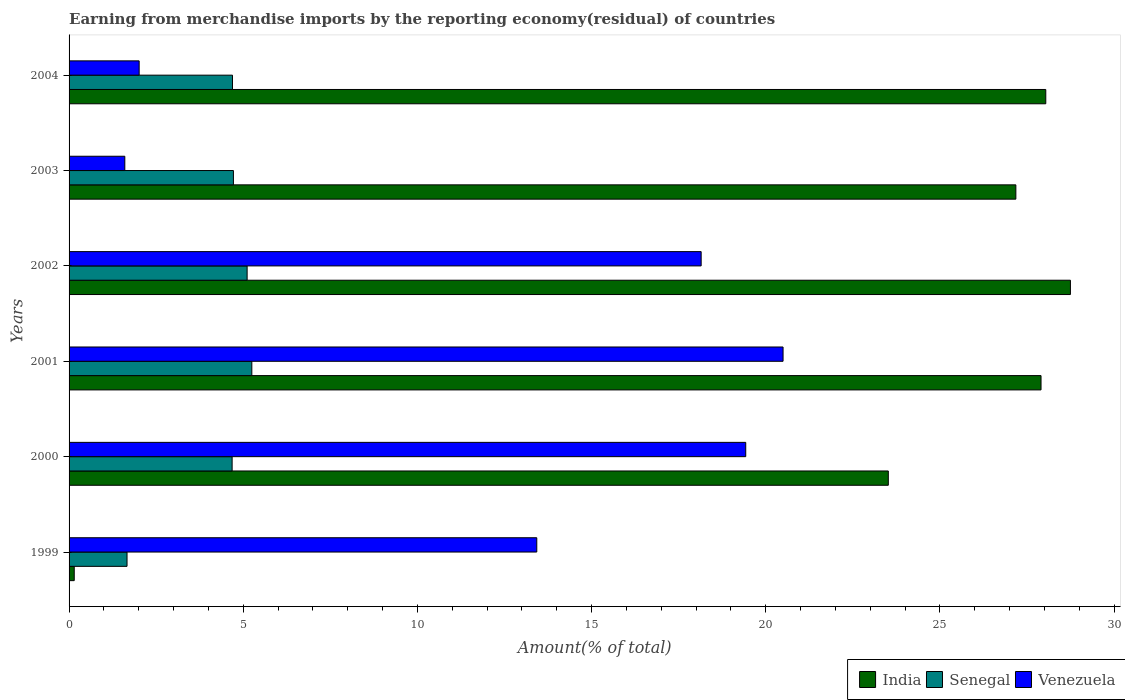How many different coloured bars are there?
Make the answer very short. 3. Are the number of bars on each tick of the Y-axis equal?
Keep it short and to the point. Yes. How many bars are there on the 2nd tick from the top?
Make the answer very short. 3. What is the label of the 3rd group of bars from the top?
Your response must be concise. 2002. What is the percentage of amount earned from merchandise imports in India in 2000?
Your answer should be very brief. 23.52. Across all years, what is the maximum percentage of amount earned from merchandise imports in India?
Give a very brief answer. 28.75. Across all years, what is the minimum percentage of amount earned from merchandise imports in Venezuela?
Keep it short and to the point. 1.6. In which year was the percentage of amount earned from merchandise imports in Venezuela maximum?
Ensure brevity in your answer.  2001. In which year was the percentage of amount earned from merchandise imports in Venezuela minimum?
Provide a short and direct response. 2003. What is the total percentage of amount earned from merchandise imports in India in the graph?
Ensure brevity in your answer.  135.53. What is the difference between the percentage of amount earned from merchandise imports in India in 2001 and that in 2003?
Your answer should be very brief. 0.72. What is the difference between the percentage of amount earned from merchandise imports in Senegal in 2001 and the percentage of amount earned from merchandise imports in India in 2003?
Give a very brief answer. -21.93. What is the average percentage of amount earned from merchandise imports in India per year?
Provide a short and direct response. 22.59. In the year 2000, what is the difference between the percentage of amount earned from merchandise imports in India and percentage of amount earned from merchandise imports in Senegal?
Keep it short and to the point. 18.84. What is the ratio of the percentage of amount earned from merchandise imports in Venezuela in 1999 to that in 2003?
Your answer should be compact. 8.39. What is the difference between the highest and the second highest percentage of amount earned from merchandise imports in India?
Your answer should be compact. 0.71. What is the difference between the highest and the lowest percentage of amount earned from merchandise imports in Venezuela?
Make the answer very short. 18.9. What does the 3rd bar from the top in 2002 represents?
Your response must be concise. India. What does the 1st bar from the bottom in 2002 represents?
Offer a very short reply. India. How many bars are there?
Keep it short and to the point. 18. Are all the bars in the graph horizontal?
Your response must be concise. Yes. How many years are there in the graph?
Give a very brief answer. 6. Are the values on the major ticks of X-axis written in scientific E-notation?
Make the answer very short. No. How many legend labels are there?
Your answer should be very brief. 3. How are the legend labels stacked?
Provide a short and direct response. Horizontal. What is the title of the graph?
Provide a succinct answer. Earning from merchandise imports by the reporting economy(residual) of countries. Does "Jordan" appear as one of the legend labels in the graph?
Your response must be concise. No. What is the label or title of the X-axis?
Keep it short and to the point. Amount(% of total). What is the Amount(% of total) in India in 1999?
Your response must be concise. 0.15. What is the Amount(% of total) of Senegal in 1999?
Your response must be concise. 1.66. What is the Amount(% of total) of Venezuela in 1999?
Make the answer very short. 13.43. What is the Amount(% of total) in India in 2000?
Your answer should be very brief. 23.52. What is the Amount(% of total) of Senegal in 2000?
Offer a terse response. 4.68. What is the Amount(% of total) of Venezuela in 2000?
Offer a terse response. 19.42. What is the Amount(% of total) of India in 2001?
Ensure brevity in your answer.  27.9. What is the Amount(% of total) in Senegal in 2001?
Provide a short and direct response. 5.25. What is the Amount(% of total) in Venezuela in 2001?
Your answer should be compact. 20.5. What is the Amount(% of total) of India in 2002?
Your answer should be compact. 28.75. What is the Amount(% of total) in Senegal in 2002?
Offer a very short reply. 5.11. What is the Amount(% of total) in Venezuela in 2002?
Provide a short and direct response. 18.14. What is the Amount(% of total) in India in 2003?
Offer a very short reply. 27.18. What is the Amount(% of total) in Senegal in 2003?
Your answer should be very brief. 4.72. What is the Amount(% of total) of Venezuela in 2003?
Keep it short and to the point. 1.6. What is the Amount(% of total) of India in 2004?
Give a very brief answer. 28.04. What is the Amount(% of total) of Senegal in 2004?
Offer a terse response. 4.69. What is the Amount(% of total) in Venezuela in 2004?
Make the answer very short. 2.01. Across all years, what is the maximum Amount(% of total) of India?
Ensure brevity in your answer.  28.75. Across all years, what is the maximum Amount(% of total) of Senegal?
Offer a terse response. 5.25. Across all years, what is the maximum Amount(% of total) of Venezuela?
Offer a very short reply. 20.5. Across all years, what is the minimum Amount(% of total) of India?
Give a very brief answer. 0.15. Across all years, what is the minimum Amount(% of total) of Senegal?
Ensure brevity in your answer.  1.66. Across all years, what is the minimum Amount(% of total) in Venezuela?
Your answer should be very brief. 1.6. What is the total Amount(% of total) of India in the graph?
Keep it short and to the point. 135.53. What is the total Amount(% of total) of Senegal in the graph?
Make the answer very short. 26.11. What is the total Amount(% of total) in Venezuela in the graph?
Offer a very short reply. 75.1. What is the difference between the Amount(% of total) in India in 1999 and that in 2000?
Keep it short and to the point. -23.37. What is the difference between the Amount(% of total) of Senegal in 1999 and that in 2000?
Provide a succinct answer. -3.02. What is the difference between the Amount(% of total) in Venezuela in 1999 and that in 2000?
Your answer should be very brief. -6. What is the difference between the Amount(% of total) in India in 1999 and that in 2001?
Provide a short and direct response. -27.75. What is the difference between the Amount(% of total) of Senegal in 1999 and that in 2001?
Your answer should be very brief. -3.58. What is the difference between the Amount(% of total) in Venezuela in 1999 and that in 2001?
Your answer should be very brief. -7.07. What is the difference between the Amount(% of total) in India in 1999 and that in 2002?
Your response must be concise. -28.6. What is the difference between the Amount(% of total) in Senegal in 1999 and that in 2002?
Keep it short and to the point. -3.45. What is the difference between the Amount(% of total) in Venezuela in 1999 and that in 2002?
Give a very brief answer. -4.72. What is the difference between the Amount(% of total) of India in 1999 and that in 2003?
Offer a very short reply. -27.03. What is the difference between the Amount(% of total) in Senegal in 1999 and that in 2003?
Offer a terse response. -3.05. What is the difference between the Amount(% of total) in Venezuela in 1999 and that in 2003?
Provide a succinct answer. 11.83. What is the difference between the Amount(% of total) of India in 1999 and that in 2004?
Provide a short and direct response. -27.89. What is the difference between the Amount(% of total) in Senegal in 1999 and that in 2004?
Provide a short and direct response. -3.03. What is the difference between the Amount(% of total) in Venezuela in 1999 and that in 2004?
Ensure brevity in your answer.  11.41. What is the difference between the Amount(% of total) in India in 2000 and that in 2001?
Ensure brevity in your answer.  -4.38. What is the difference between the Amount(% of total) of Senegal in 2000 and that in 2001?
Your response must be concise. -0.57. What is the difference between the Amount(% of total) of Venezuela in 2000 and that in 2001?
Ensure brevity in your answer.  -1.07. What is the difference between the Amount(% of total) of India in 2000 and that in 2002?
Your response must be concise. -5.23. What is the difference between the Amount(% of total) in Senegal in 2000 and that in 2002?
Offer a terse response. -0.43. What is the difference between the Amount(% of total) of Venezuela in 2000 and that in 2002?
Offer a terse response. 1.28. What is the difference between the Amount(% of total) in India in 2000 and that in 2003?
Provide a short and direct response. -3.66. What is the difference between the Amount(% of total) of Senegal in 2000 and that in 2003?
Offer a very short reply. -0.04. What is the difference between the Amount(% of total) in Venezuela in 2000 and that in 2003?
Your answer should be compact. 17.82. What is the difference between the Amount(% of total) of India in 2000 and that in 2004?
Your answer should be very brief. -4.52. What is the difference between the Amount(% of total) of Senegal in 2000 and that in 2004?
Your response must be concise. -0.01. What is the difference between the Amount(% of total) in Venezuela in 2000 and that in 2004?
Provide a succinct answer. 17.41. What is the difference between the Amount(% of total) in India in 2001 and that in 2002?
Make the answer very short. -0.84. What is the difference between the Amount(% of total) in Senegal in 2001 and that in 2002?
Offer a very short reply. 0.14. What is the difference between the Amount(% of total) of Venezuela in 2001 and that in 2002?
Ensure brevity in your answer.  2.35. What is the difference between the Amount(% of total) of India in 2001 and that in 2003?
Provide a succinct answer. 0.72. What is the difference between the Amount(% of total) of Senegal in 2001 and that in 2003?
Your answer should be very brief. 0.53. What is the difference between the Amount(% of total) in Venezuela in 2001 and that in 2003?
Give a very brief answer. 18.9. What is the difference between the Amount(% of total) in India in 2001 and that in 2004?
Your answer should be very brief. -0.14. What is the difference between the Amount(% of total) in Senegal in 2001 and that in 2004?
Make the answer very short. 0.56. What is the difference between the Amount(% of total) of Venezuela in 2001 and that in 2004?
Your response must be concise. 18.48. What is the difference between the Amount(% of total) in India in 2002 and that in 2003?
Your answer should be very brief. 1.57. What is the difference between the Amount(% of total) in Senegal in 2002 and that in 2003?
Provide a succinct answer. 0.39. What is the difference between the Amount(% of total) of Venezuela in 2002 and that in 2003?
Give a very brief answer. 16.54. What is the difference between the Amount(% of total) of India in 2002 and that in 2004?
Offer a very short reply. 0.71. What is the difference between the Amount(% of total) of Senegal in 2002 and that in 2004?
Provide a succinct answer. 0.42. What is the difference between the Amount(% of total) in Venezuela in 2002 and that in 2004?
Offer a terse response. 16.13. What is the difference between the Amount(% of total) of India in 2003 and that in 2004?
Make the answer very short. -0.86. What is the difference between the Amount(% of total) in Senegal in 2003 and that in 2004?
Offer a terse response. 0.03. What is the difference between the Amount(% of total) in Venezuela in 2003 and that in 2004?
Give a very brief answer. -0.41. What is the difference between the Amount(% of total) of India in 1999 and the Amount(% of total) of Senegal in 2000?
Give a very brief answer. -4.53. What is the difference between the Amount(% of total) of India in 1999 and the Amount(% of total) of Venezuela in 2000?
Ensure brevity in your answer.  -19.28. What is the difference between the Amount(% of total) in Senegal in 1999 and the Amount(% of total) in Venezuela in 2000?
Offer a terse response. -17.76. What is the difference between the Amount(% of total) of India in 1999 and the Amount(% of total) of Senegal in 2001?
Offer a very short reply. -5.1. What is the difference between the Amount(% of total) of India in 1999 and the Amount(% of total) of Venezuela in 2001?
Your answer should be compact. -20.35. What is the difference between the Amount(% of total) in Senegal in 1999 and the Amount(% of total) in Venezuela in 2001?
Your response must be concise. -18.83. What is the difference between the Amount(% of total) in India in 1999 and the Amount(% of total) in Senegal in 2002?
Your answer should be very brief. -4.96. What is the difference between the Amount(% of total) of India in 1999 and the Amount(% of total) of Venezuela in 2002?
Offer a very short reply. -18. What is the difference between the Amount(% of total) of Senegal in 1999 and the Amount(% of total) of Venezuela in 2002?
Offer a very short reply. -16.48. What is the difference between the Amount(% of total) of India in 1999 and the Amount(% of total) of Senegal in 2003?
Give a very brief answer. -4.57. What is the difference between the Amount(% of total) in India in 1999 and the Amount(% of total) in Venezuela in 2003?
Provide a succinct answer. -1.45. What is the difference between the Amount(% of total) in Senegal in 1999 and the Amount(% of total) in Venezuela in 2003?
Offer a very short reply. 0.06. What is the difference between the Amount(% of total) of India in 1999 and the Amount(% of total) of Senegal in 2004?
Provide a short and direct response. -4.54. What is the difference between the Amount(% of total) in India in 1999 and the Amount(% of total) in Venezuela in 2004?
Offer a terse response. -1.86. What is the difference between the Amount(% of total) of Senegal in 1999 and the Amount(% of total) of Venezuela in 2004?
Your response must be concise. -0.35. What is the difference between the Amount(% of total) of India in 2000 and the Amount(% of total) of Senegal in 2001?
Keep it short and to the point. 18.27. What is the difference between the Amount(% of total) of India in 2000 and the Amount(% of total) of Venezuela in 2001?
Your response must be concise. 3.02. What is the difference between the Amount(% of total) of Senegal in 2000 and the Amount(% of total) of Venezuela in 2001?
Your answer should be very brief. -15.82. What is the difference between the Amount(% of total) in India in 2000 and the Amount(% of total) in Senegal in 2002?
Ensure brevity in your answer.  18.41. What is the difference between the Amount(% of total) of India in 2000 and the Amount(% of total) of Venezuela in 2002?
Offer a very short reply. 5.37. What is the difference between the Amount(% of total) in Senegal in 2000 and the Amount(% of total) in Venezuela in 2002?
Keep it short and to the point. -13.46. What is the difference between the Amount(% of total) in India in 2000 and the Amount(% of total) in Senegal in 2003?
Offer a very short reply. 18.8. What is the difference between the Amount(% of total) in India in 2000 and the Amount(% of total) in Venezuela in 2003?
Ensure brevity in your answer.  21.92. What is the difference between the Amount(% of total) of Senegal in 2000 and the Amount(% of total) of Venezuela in 2003?
Provide a short and direct response. 3.08. What is the difference between the Amount(% of total) of India in 2000 and the Amount(% of total) of Senegal in 2004?
Your answer should be very brief. 18.83. What is the difference between the Amount(% of total) in India in 2000 and the Amount(% of total) in Venezuela in 2004?
Your answer should be very brief. 21.51. What is the difference between the Amount(% of total) in Senegal in 2000 and the Amount(% of total) in Venezuela in 2004?
Keep it short and to the point. 2.67. What is the difference between the Amount(% of total) of India in 2001 and the Amount(% of total) of Senegal in 2002?
Make the answer very short. 22.79. What is the difference between the Amount(% of total) in India in 2001 and the Amount(% of total) in Venezuela in 2002?
Provide a short and direct response. 9.76. What is the difference between the Amount(% of total) of Senegal in 2001 and the Amount(% of total) of Venezuela in 2002?
Offer a very short reply. -12.9. What is the difference between the Amount(% of total) of India in 2001 and the Amount(% of total) of Senegal in 2003?
Ensure brevity in your answer.  23.18. What is the difference between the Amount(% of total) in India in 2001 and the Amount(% of total) in Venezuela in 2003?
Your answer should be very brief. 26.3. What is the difference between the Amount(% of total) in Senegal in 2001 and the Amount(% of total) in Venezuela in 2003?
Your answer should be very brief. 3.65. What is the difference between the Amount(% of total) of India in 2001 and the Amount(% of total) of Senegal in 2004?
Ensure brevity in your answer.  23.21. What is the difference between the Amount(% of total) of India in 2001 and the Amount(% of total) of Venezuela in 2004?
Your response must be concise. 25.89. What is the difference between the Amount(% of total) in Senegal in 2001 and the Amount(% of total) in Venezuela in 2004?
Your answer should be compact. 3.23. What is the difference between the Amount(% of total) of India in 2002 and the Amount(% of total) of Senegal in 2003?
Your answer should be compact. 24.03. What is the difference between the Amount(% of total) of India in 2002 and the Amount(% of total) of Venezuela in 2003?
Keep it short and to the point. 27.14. What is the difference between the Amount(% of total) in Senegal in 2002 and the Amount(% of total) in Venezuela in 2003?
Provide a short and direct response. 3.51. What is the difference between the Amount(% of total) of India in 2002 and the Amount(% of total) of Senegal in 2004?
Keep it short and to the point. 24.05. What is the difference between the Amount(% of total) in India in 2002 and the Amount(% of total) in Venezuela in 2004?
Ensure brevity in your answer.  26.73. What is the difference between the Amount(% of total) in Senegal in 2002 and the Amount(% of total) in Venezuela in 2004?
Offer a terse response. 3.1. What is the difference between the Amount(% of total) in India in 2003 and the Amount(% of total) in Senegal in 2004?
Provide a short and direct response. 22.49. What is the difference between the Amount(% of total) of India in 2003 and the Amount(% of total) of Venezuela in 2004?
Offer a very short reply. 25.17. What is the difference between the Amount(% of total) of Senegal in 2003 and the Amount(% of total) of Venezuela in 2004?
Make the answer very short. 2.71. What is the average Amount(% of total) of India per year?
Offer a very short reply. 22.59. What is the average Amount(% of total) of Senegal per year?
Your answer should be compact. 4.35. What is the average Amount(% of total) in Venezuela per year?
Your response must be concise. 12.52. In the year 1999, what is the difference between the Amount(% of total) of India and Amount(% of total) of Senegal?
Your answer should be compact. -1.52. In the year 1999, what is the difference between the Amount(% of total) of India and Amount(% of total) of Venezuela?
Ensure brevity in your answer.  -13.28. In the year 1999, what is the difference between the Amount(% of total) in Senegal and Amount(% of total) in Venezuela?
Your answer should be very brief. -11.76. In the year 2000, what is the difference between the Amount(% of total) of India and Amount(% of total) of Senegal?
Your answer should be compact. 18.84. In the year 2000, what is the difference between the Amount(% of total) of India and Amount(% of total) of Venezuela?
Provide a short and direct response. 4.09. In the year 2000, what is the difference between the Amount(% of total) of Senegal and Amount(% of total) of Venezuela?
Offer a very short reply. -14.74. In the year 2001, what is the difference between the Amount(% of total) of India and Amount(% of total) of Senegal?
Make the answer very short. 22.66. In the year 2001, what is the difference between the Amount(% of total) in India and Amount(% of total) in Venezuela?
Make the answer very short. 7.41. In the year 2001, what is the difference between the Amount(% of total) in Senegal and Amount(% of total) in Venezuela?
Provide a succinct answer. -15.25. In the year 2002, what is the difference between the Amount(% of total) in India and Amount(% of total) in Senegal?
Ensure brevity in your answer.  23.63. In the year 2002, what is the difference between the Amount(% of total) in India and Amount(% of total) in Venezuela?
Provide a succinct answer. 10.6. In the year 2002, what is the difference between the Amount(% of total) in Senegal and Amount(% of total) in Venezuela?
Your answer should be very brief. -13.03. In the year 2003, what is the difference between the Amount(% of total) in India and Amount(% of total) in Senegal?
Offer a very short reply. 22.46. In the year 2003, what is the difference between the Amount(% of total) in India and Amount(% of total) in Venezuela?
Your response must be concise. 25.58. In the year 2003, what is the difference between the Amount(% of total) of Senegal and Amount(% of total) of Venezuela?
Offer a terse response. 3.12. In the year 2004, what is the difference between the Amount(% of total) in India and Amount(% of total) in Senegal?
Provide a short and direct response. 23.35. In the year 2004, what is the difference between the Amount(% of total) in India and Amount(% of total) in Venezuela?
Provide a short and direct response. 26.03. In the year 2004, what is the difference between the Amount(% of total) in Senegal and Amount(% of total) in Venezuela?
Your answer should be compact. 2.68. What is the ratio of the Amount(% of total) of India in 1999 to that in 2000?
Ensure brevity in your answer.  0.01. What is the ratio of the Amount(% of total) in Senegal in 1999 to that in 2000?
Your answer should be compact. 0.36. What is the ratio of the Amount(% of total) in Venezuela in 1999 to that in 2000?
Your answer should be compact. 0.69. What is the ratio of the Amount(% of total) in India in 1999 to that in 2001?
Offer a terse response. 0.01. What is the ratio of the Amount(% of total) in Senegal in 1999 to that in 2001?
Keep it short and to the point. 0.32. What is the ratio of the Amount(% of total) in Venezuela in 1999 to that in 2001?
Make the answer very short. 0.66. What is the ratio of the Amount(% of total) in India in 1999 to that in 2002?
Your answer should be compact. 0.01. What is the ratio of the Amount(% of total) of Senegal in 1999 to that in 2002?
Your response must be concise. 0.33. What is the ratio of the Amount(% of total) of Venezuela in 1999 to that in 2002?
Your answer should be very brief. 0.74. What is the ratio of the Amount(% of total) of India in 1999 to that in 2003?
Your answer should be very brief. 0.01. What is the ratio of the Amount(% of total) of Senegal in 1999 to that in 2003?
Your response must be concise. 0.35. What is the ratio of the Amount(% of total) in Venezuela in 1999 to that in 2003?
Give a very brief answer. 8.39. What is the ratio of the Amount(% of total) in India in 1999 to that in 2004?
Ensure brevity in your answer.  0.01. What is the ratio of the Amount(% of total) of Senegal in 1999 to that in 2004?
Offer a very short reply. 0.35. What is the ratio of the Amount(% of total) of Venezuela in 1999 to that in 2004?
Keep it short and to the point. 6.67. What is the ratio of the Amount(% of total) in India in 2000 to that in 2001?
Your answer should be very brief. 0.84. What is the ratio of the Amount(% of total) in Senegal in 2000 to that in 2001?
Give a very brief answer. 0.89. What is the ratio of the Amount(% of total) of Venezuela in 2000 to that in 2001?
Your answer should be compact. 0.95. What is the ratio of the Amount(% of total) of India in 2000 to that in 2002?
Your answer should be compact. 0.82. What is the ratio of the Amount(% of total) in Senegal in 2000 to that in 2002?
Keep it short and to the point. 0.92. What is the ratio of the Amount(% of total) of Venezuela in 2000 to that in 2002?
Offer a terse response. 1.07. What is the ratio of the Amount(% of total) in India in 2000 to that in 2003?
Provide a succinct answer. 0.87. What is the ratio of the Amount(% of total) in Venezuela in 2000 to that in 2003?
Keep it short and to the point. 12.14. What is the ratio of the Amount(% of total) in India in 2000 to that in 2004?
Your answer should be very brief. 0.84. What is the ratio of the Amount(% of total) in Venezuela in 2000 to that in 2004?
Make the answer very short. 9.65. What is the ratio of the Amount(% of total) of India in 2001 to that in 2002?
Your answer should be very brief. 0.97. What is the ratio of the Amount(% of total) in Senegal in 2001 to that in 2002?
Your answer should be very brief. 1.03. What is the ratio of the Amount(% of total) of Venezuela in 2001 to that in 2002?
Your answer should be very brief. 1.13. What is the ratio of the Amount(% of total) of India in 2001 to that in 2003?
Your response must be concise. 1.03. What is the ratio of the Amount(% of total) of Senegal in 2001 to that in 2003?
Your answer should be very brief. 1.11. What is the ratio of the Amount(% of total) in Venezuela in 2001 to that in 2003?
Your answer should be compact. 12.81. What is the ratio of the Amount(% of total) in Senegal in 2001 to that in 2004?
Make the answer very short. 1.12. What is the ratio of the Amount(% of total) in Venezuela in 2001 to that in 2004?
Offer a terse response. 10.19. What is the ratio of the Amount(% of total) of India in 2002 to that in 2003?
Offer a terse response. 1.06. What is the ratio of the Amount(% of total) of Senegal in 2002 to that in 2003?
Provide a succinct answer. 1.08. What is the ratio of the Amount(% of total) in Venezuela in 2002 to that in 2003?
Your answer should be very brief. 11.34. What is the ratio of the Amount(% of total) of India in 2002 to that in 2004?
Give a very brief answer. 1.03. What is the ratio of the Amount(% of total) of Senegal in 2002 to that in 2004?
Offer a very short reply. 1.09. What is the ratio of the Amount(% of total) of Venezuela in 2002 to that in 2004?
Make the answer very short. 9.02. What is the ratio of the Amount(% of total) of India in 2003 to that in 2004?
Keep it short and to the point. 0.97. What is the ratio of the Amount(% of total) of Venezuela in 2003 to that in 2004?
Provide a short and direct response. 0.8. What is the difference between the highest and the second highest Amount(% of total) of India?
Your answer should be very brief. 0.71. What is the difference between the highest and the second highest Amount(% of total) in Senegal?
Keep it short and to the point. 0.14. What is the difference between the highest and the second highest Amount(% of total) of Venezuela?
Give a very brief answer. 1.07. What is the difference between the highest and the lowest Amount(% of total) in India?
Offer a terse response. 28.6. What is the difference between the highest and the lowest Amount(% of total) in Senegal?
Your answer should be compact. 3.58. What is the difference between the highest and the lowest Amount(% of total) of Venezuela?
Your response must be concise. 18.9. 